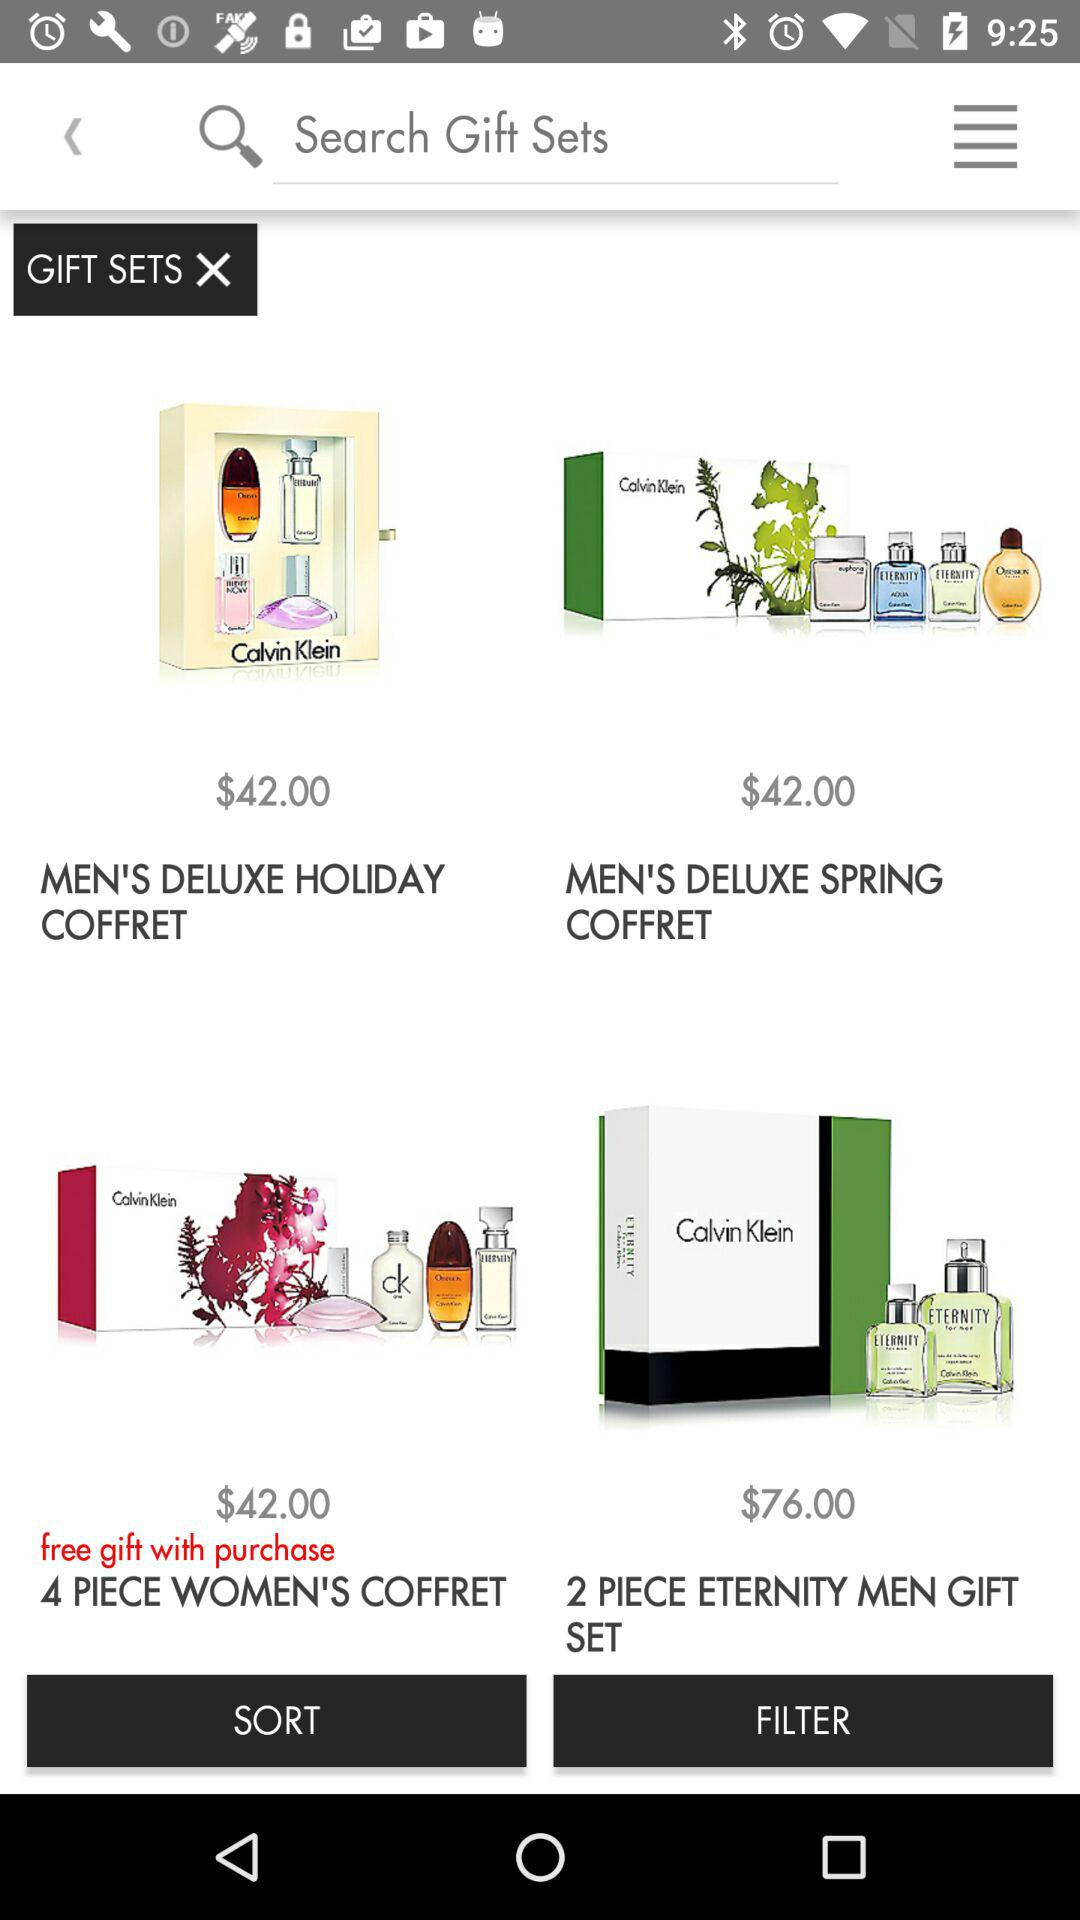Which product gives free gifts with purchase? The product is the 4 piece women's coffret. 